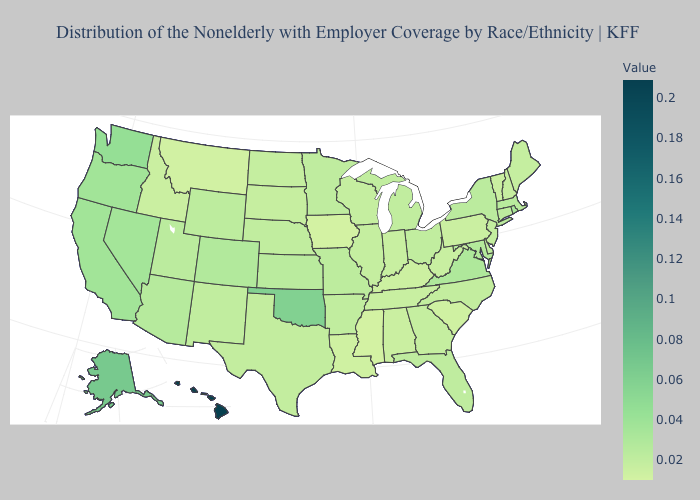Does Hawaii have the highest value in the USA?
Quick response, please. Yes. Among the states that border Idaho , does Montana have the lowest value?
Short answer required. Yes. Among the states that border Kansas , which have the highest value?
Be succinct. Oklahoma. Among the states that border Michigan , does Wisconsin have the highest value?
Keep it brief. No. Does the map have missing data?
Be succinct. No. 